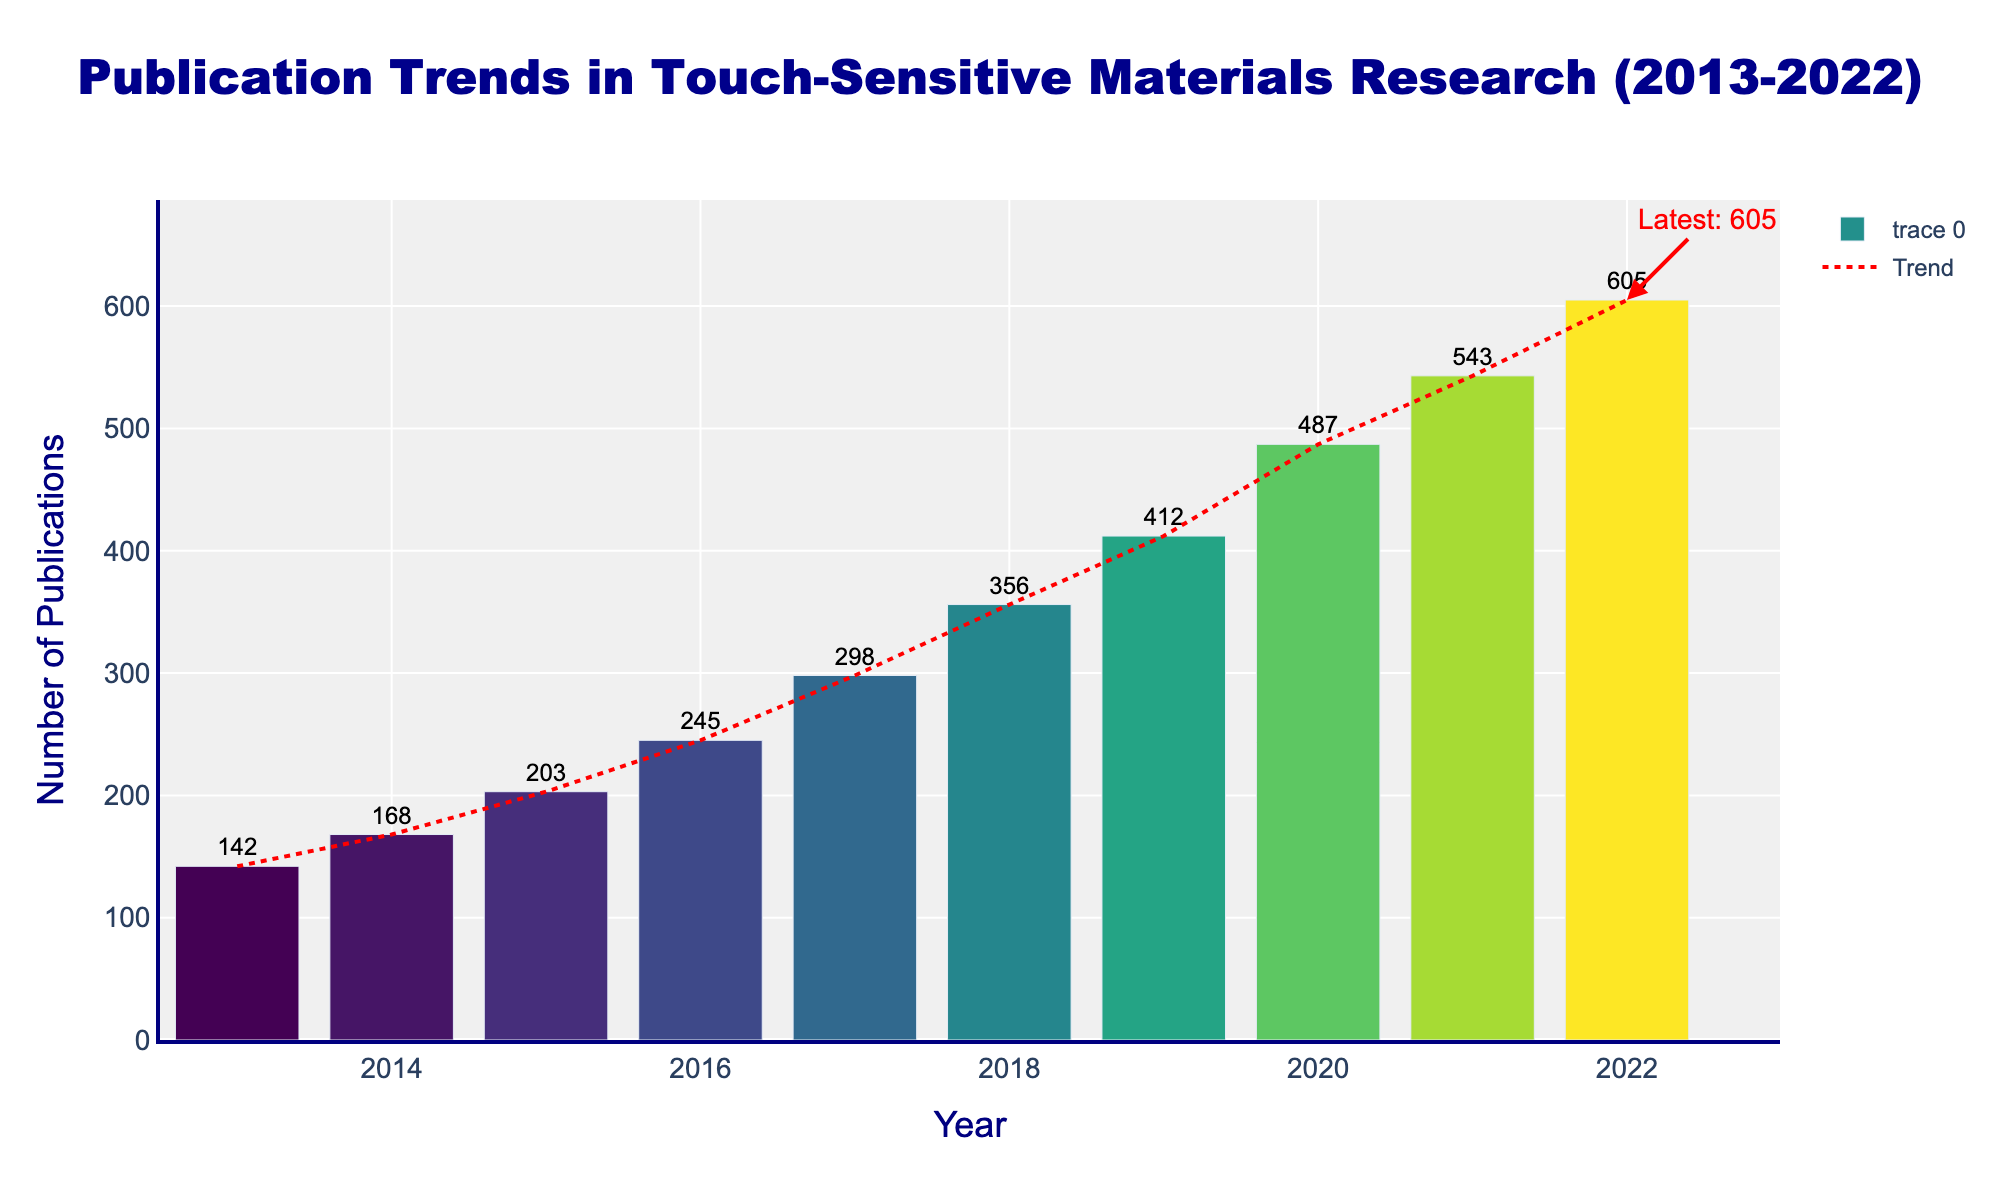What's the total number of publications from 2013 to 2016? Sum the number of publications for each year from 2013 to 2016. That is, 142 (2013) + 168 (2014) + 203 (2015) + 245 (2016) = 758
Answer: 758 Which year saw the highest number of publications? Look at the top of each bar to see which one is the highest. The bar for 2022 is the highest, indicating 605 publications
Answer: 2022 How did the number of publications change from 2020 to 2021? Subtract the number of publications in 2020 from 2021. That is, 543 (2021) - 487 (2020) = 56
Answer: Increased by 56 What is the average number of publications per year between 2019 and 2022? Sum the number of publications from 2019 to 2022 and divide by the number of years. That is, (412 + 487 + 543 + 605) / 4 = 2047 / 4 = 511.75
Answer: 511.75 Is the rate of increase in publications higher from 2019 to 2020 or from 2020 to 2021? Calculate the differences: 487 (2020) - 412 (2019) = 75 and 543 (2021) - 487 (2020) = 56. Compare the differences, 75 > 56
Answer: 2019 to 2020 By how much did the number of publications increase from 2013 to 2022? Subtract the number of publications in 2013 from 2022. That is, 605 (2022) - 142 (2013) = 463
Answer: 463 While looking at the trend line, what can be inferred about the overall trend in publications from 2013 to 2022? The trend line increases as it moves from left to right, indicating an overall upward trend in the number of publications over the years
Answer: Upward trend How many more publications were there in 2018 compared to 2015? Subtract the number of publications in 2015 from 2018. That is, 356 (2018) - 203 (2015) = 153
Answer: 153 Which color predominantly represents the years with the highest and lowest number of publications? The highest number of publications (2022) is represented by a lighter color and the lowest (2013) by a darker color on the Viridis scale
Answer: Lighter and darker colors respectively What does the annotation at the end of 2022 indicate? The annotation indicates the latest number of publications, which is 605, highlighting the value with an arrow
Answer: Latest: 605 